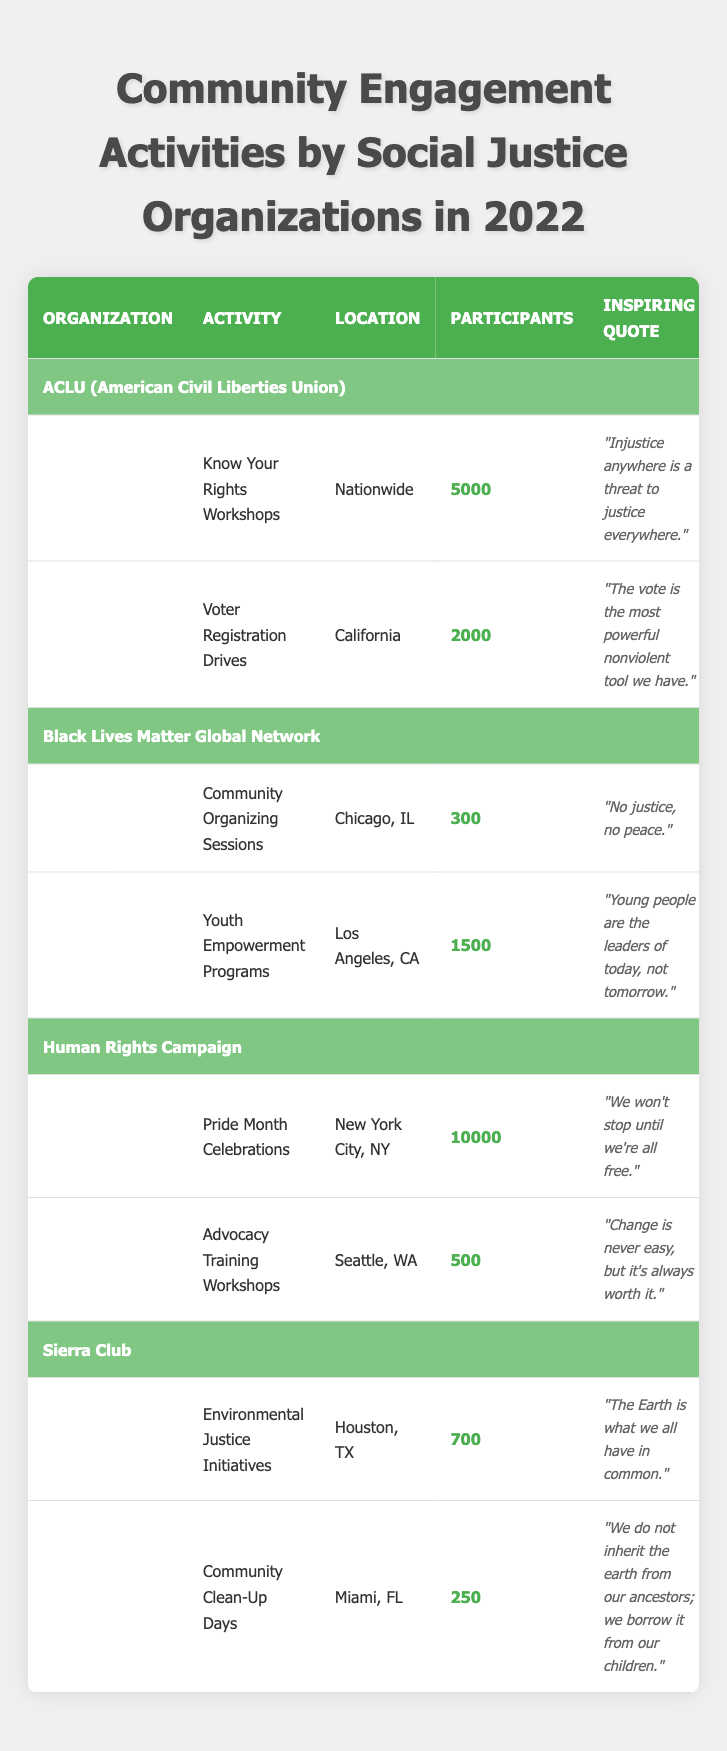What is the total number of participants in the ACLU activities? The ACLU has two activities: "Know Your Rights Workshops" with 5000 participants and "Voter Registration Drives" with 2000 participants. Adding these together gives 5000 + 2000 = 7000 participants total for ACLU.
Answer: 7000 Which organization had the highest number of participants in a single activity? Looking at the table, "Pride Month Celebrations" organized by the Human Rights Campaign had 10000 participants, which is more than any other single activity listed.
Answer: Human Rights Campaign True or False: The Sierra Club organized more participants in its activities than the Black Lives Matter Global Network. The Sierra Club had 700 (Environmental Justice Initiatives) + 250 (Community Clean-Up Days) = 950 participants. The Black Lives Matter Global Network had 300 (Community Organizing Sessions) + 1500 (Youth Empowerment Programs) = 1800 participants. Since 950 is less than 1800, the statement is false.
Answer: False What is the average number of participants across all activities listed? To find the average, add all participants: 5000 (ACLU) + 2000 (ACLU) + 300 (BLM) + 1500 (BLM) + 10000 (HRC) + 500 (HRC) + 700 (Sierra Club) + 250 (Sierra Club) = 19300. There are 8 activities, so the average is 19300 / 8 = 2412.5 participants.
Answer: 2412.5 Which quote is associated with the "Youth Empowerment Programs"? The "Youth Empowerment Programs" activity listed under the Black Lives Matter Global Network is associated with the quote "Young people are the leaders of today, not tomorrow."
Answer: "Young people are the leaders of today, not tomorrow." 